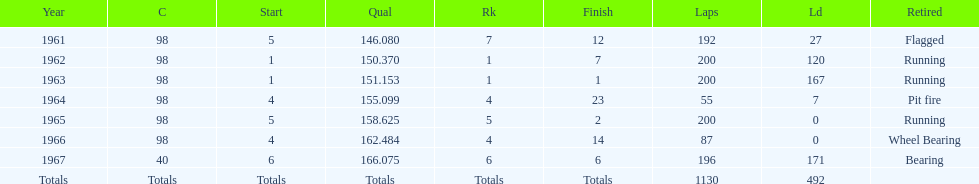In how many indy 500 races, has jones been flagged? 1. 